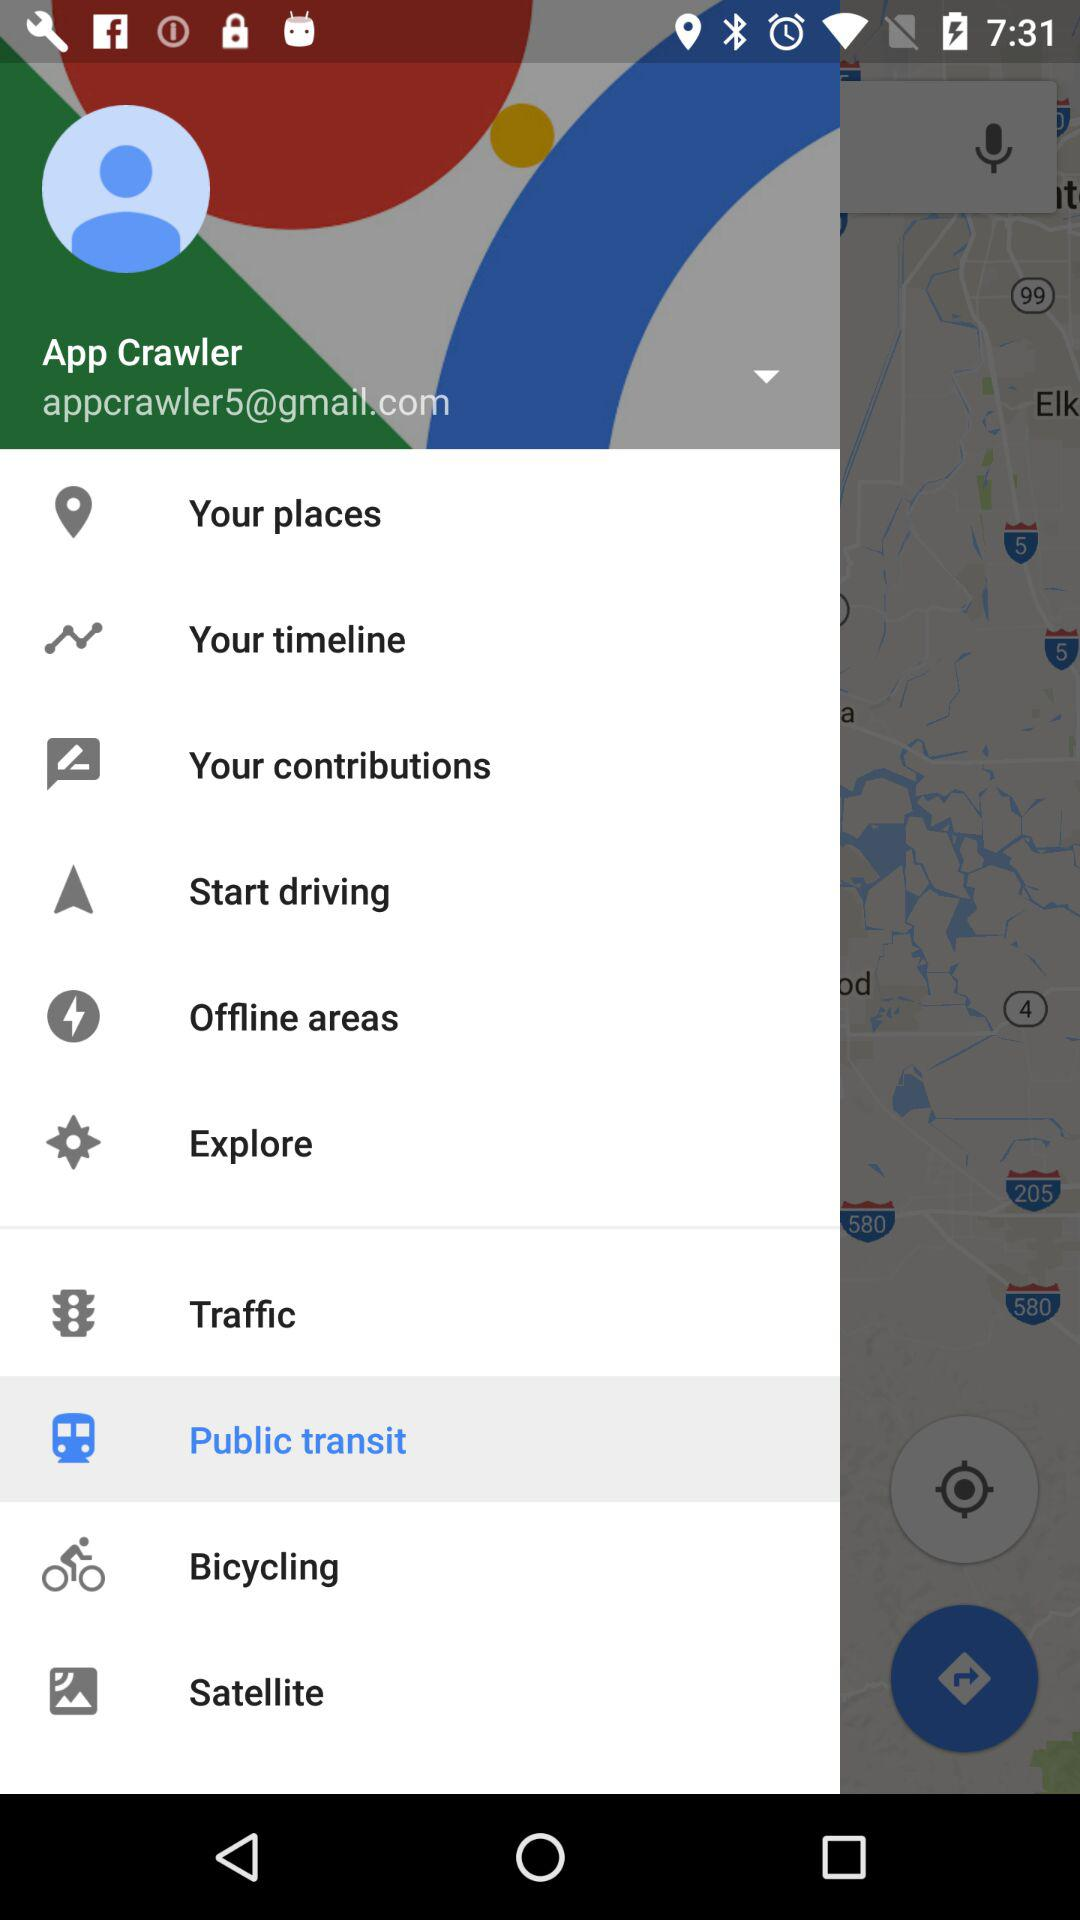What is the email address? The email address is appcrawler5@gmail.com. 